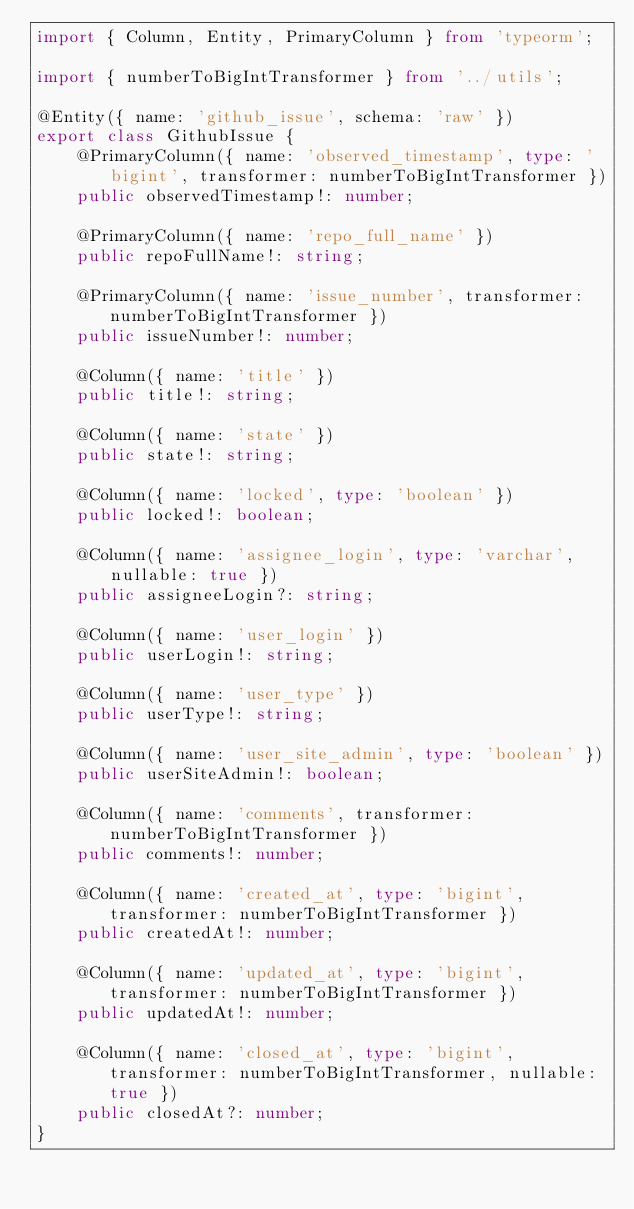Convert code to text. <code><loc_0><loc_0><loc_500><loc_500><_TypeScript_>import { Column, Entity, PrimaryColumn } from 'typeorm';

import { numberToBigIntTransformer } from '../utils';

@Entity({ name: 'github_issue', schema: 'raw' })
export class GithubIssue {
    @PrimaryColumn({ name: 'observed_timestamp', type: 'bigint', transformer: numberToBigIntTransformer })
    public observedTimestamp!: number;

    @PrimaryColumn({ name: 'repo_full_name' })
    public repoFullName!: string;

    @PrimaryColumn({ name: 'issue_number', transformer: numberToBigIntTransformer })
    public issueNumber!: number;

    @Column({ name: 'title' })
    public title!: string;

    @Column({ name: 'state' })
    public state!: string;

    @Column({ name: 'locked', type: 'boolean' })
    public locked!: boolean;

    @Column({ name: 'assignee_login', type: 'varchar', nullable: true })
    public assigneeLogin?: string;

    @Column({ name: 'user_login' })
    public userLogin!: string;

    @Column({ name: 'user_type' })
    public userType!: string;

    @Column({ name: 'user_site_admin', type: 'boolean' })
    public userSiteAdmin!: boolean;

    @Column({ name: 'comments', transformer: numberToBigIntTransformer })
    public comments!: number;

    @Column({ name: 'created_at', type: 'bigint', transformer: numberToBigIntTransformer })
    public createdAt!: number;

    @Column({ name: 'updated_at', type: 'bigint', transformer: numberToBigIntTransformer })
    public updatedAt!: number;

    @Column({ name: 'closed_at', type: 'bigint', transformer: numberToBigIntTransformer, nullable: true })
    public closedAt?: number;
}
</code> 